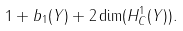Convert formula to latex. <formula><loc_0><loc_0><loc_500><loc_500>1 + b _ { 1 } ( Y ) + 2 \dim ( H ^ { 1 } _ { C } ( Y ) ) .</formula> 